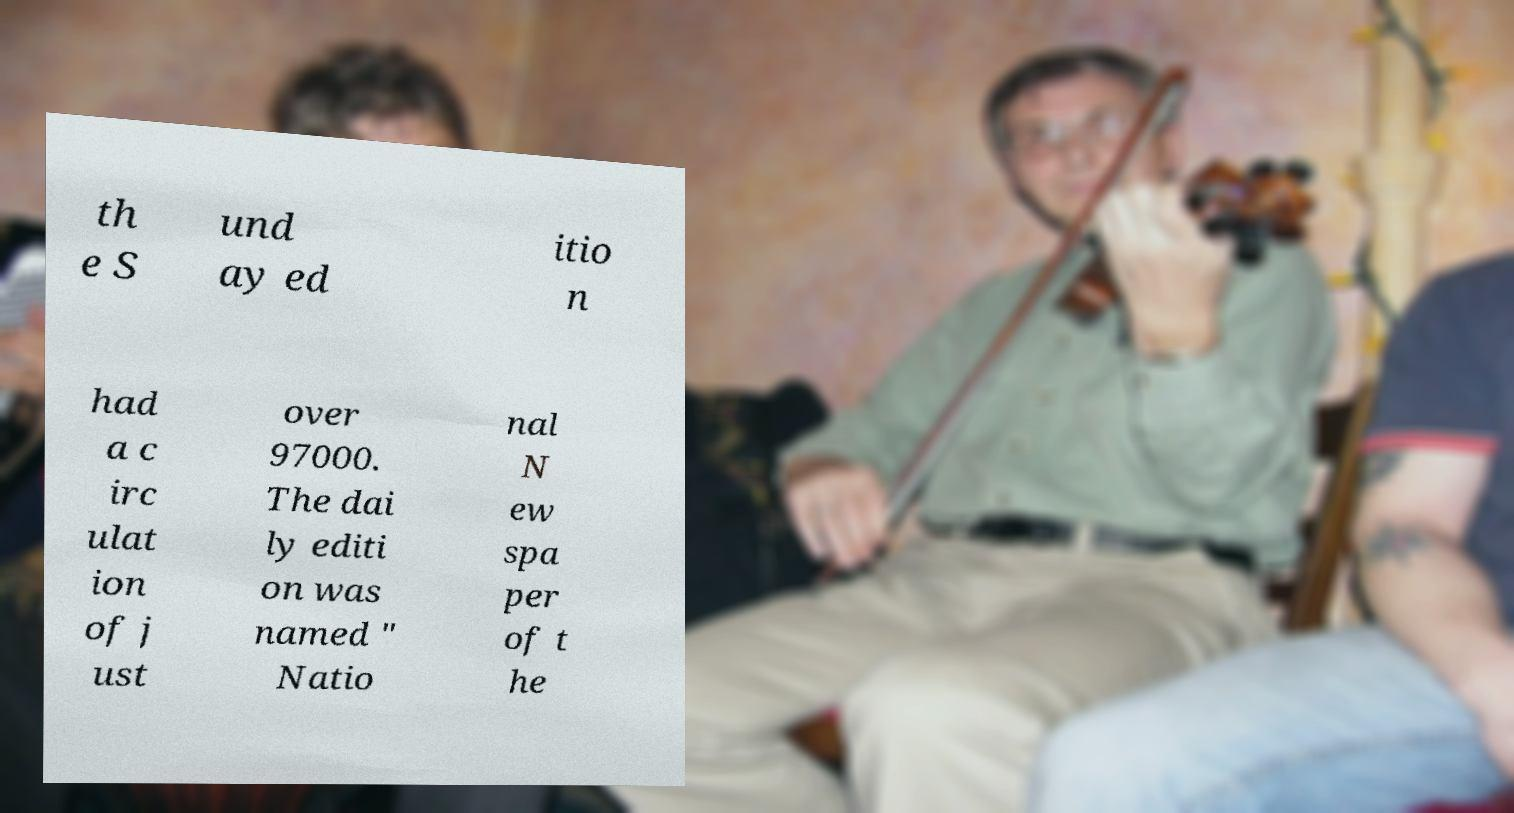Can you read and provide the text displayed in the image?This photo seems to have some interesting text. Can you extract and type it out for me? th e S und ay ed itio n had a c irc ulat ion of j ust over 97000. The dai ly editi on was named " Natio nal N ew spa per of t he 